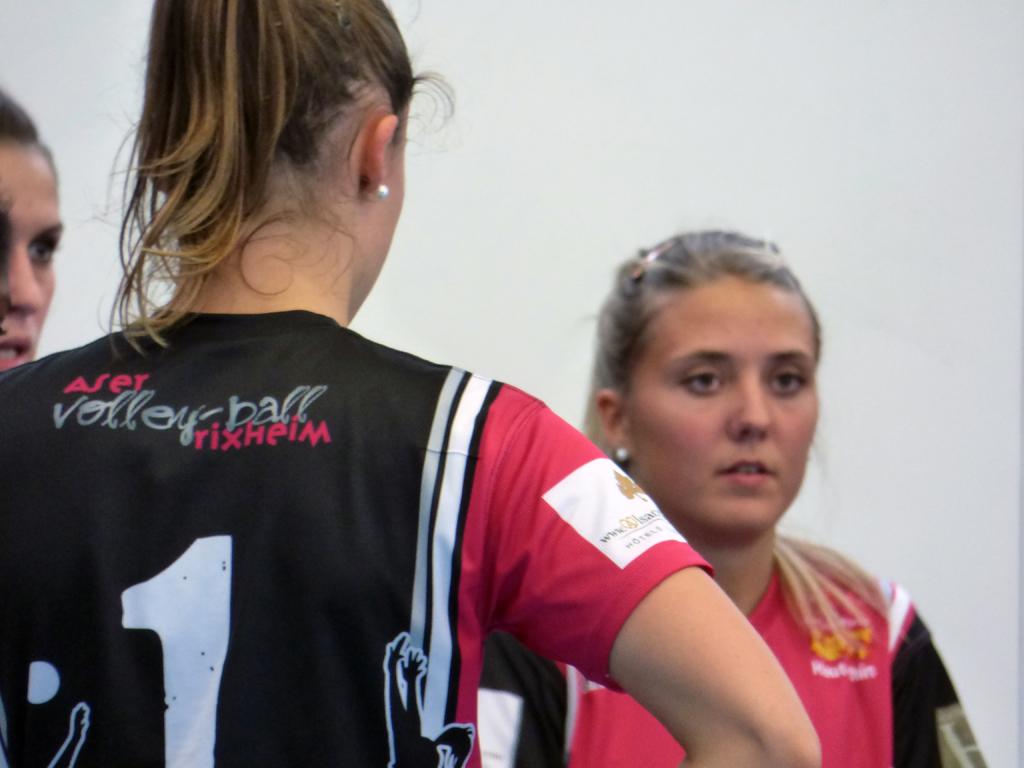What sport is mentioned on the back of the woman's shirt?
Ensure brevity in your answer.  Volleyball. What number is on the black jersey?
Provide a succinct answer. 1. 